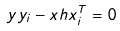Convert formula to latex. <formula><loc_0><loc_0><loc_500><loc_500>y y _ { i } - { x } h { x } ^ { T } _ { i } = 0</formula> 